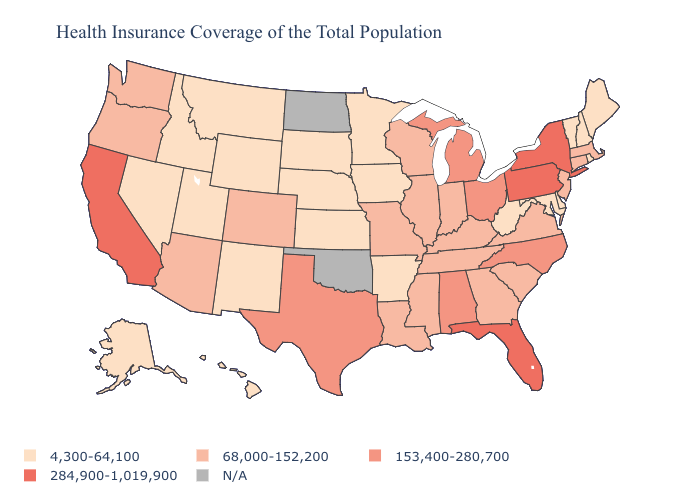Among the states that border Arkansas , which have the highest value?
Short answer required. Texas. Name the states that have a value in the range N/A?
Answer briefly. North Dakota, Oklahoma. What is the value of Delaware?
Write a very short answer. 4,300-64,100. What is the value of Michigan?
Concise answer only. 153,400-280,700. Name the states that have a value in the range 4,300-64,100?
Keep it brief. Alaska, Arkansas, Delaware, Hawaii, Idaho, Iowa, Kansas, Maine, Maryland, Minnesota, Montana, Nebraska, Nevada, New Hampshire, New Mexico, Rhode Island, South Dakota, Utah, Vermont, West Virginia, Wyoming. Name the states that have a value in the range 153,400-280,700?
Keep it brief. Alabama, Michigan, North Carolina, Ohio, Texas. Is the legend a continuous bar?
Concise answer only. No. Name the states that have a value in the range 284,900-1,019,900?
Be succinct. California, Florida, New York, Pennsylvania. Name the states that have a value in the range N/A?
Answer briefly. North Dakota, Oklahoma. Among the states that border Nevada , does Oregon have the lowest value?
Short answer required. No. How many symbols are there in the legend?
Give a very brief answer. 5. 